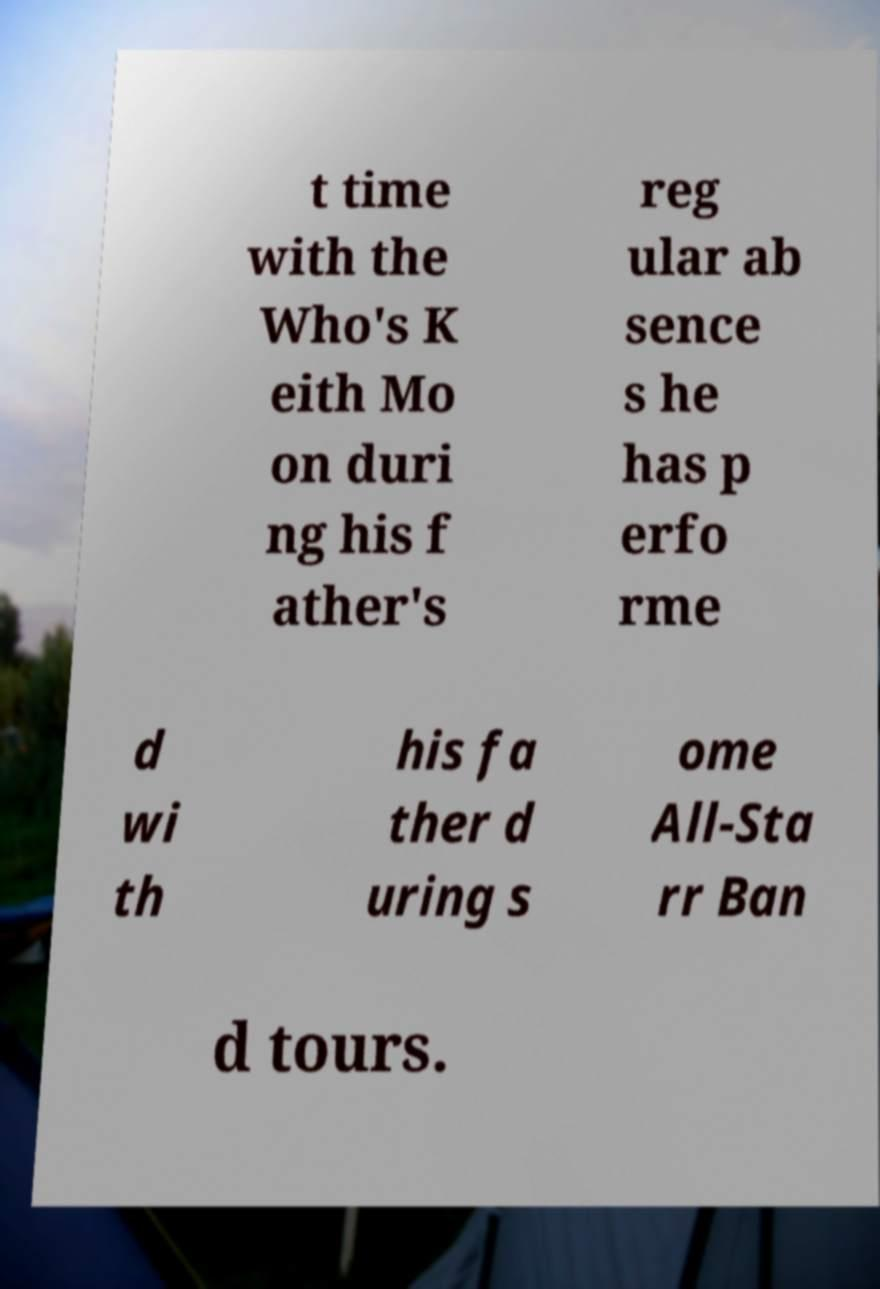Please read and relay the text visible in this image. What does it say? t time with the Who's K eith Mo on duri ng his f ather's reg ular ab sence s he has p erfo rme d wi th his fa ther d uring s ome All-Sta rr Ban d tours. 